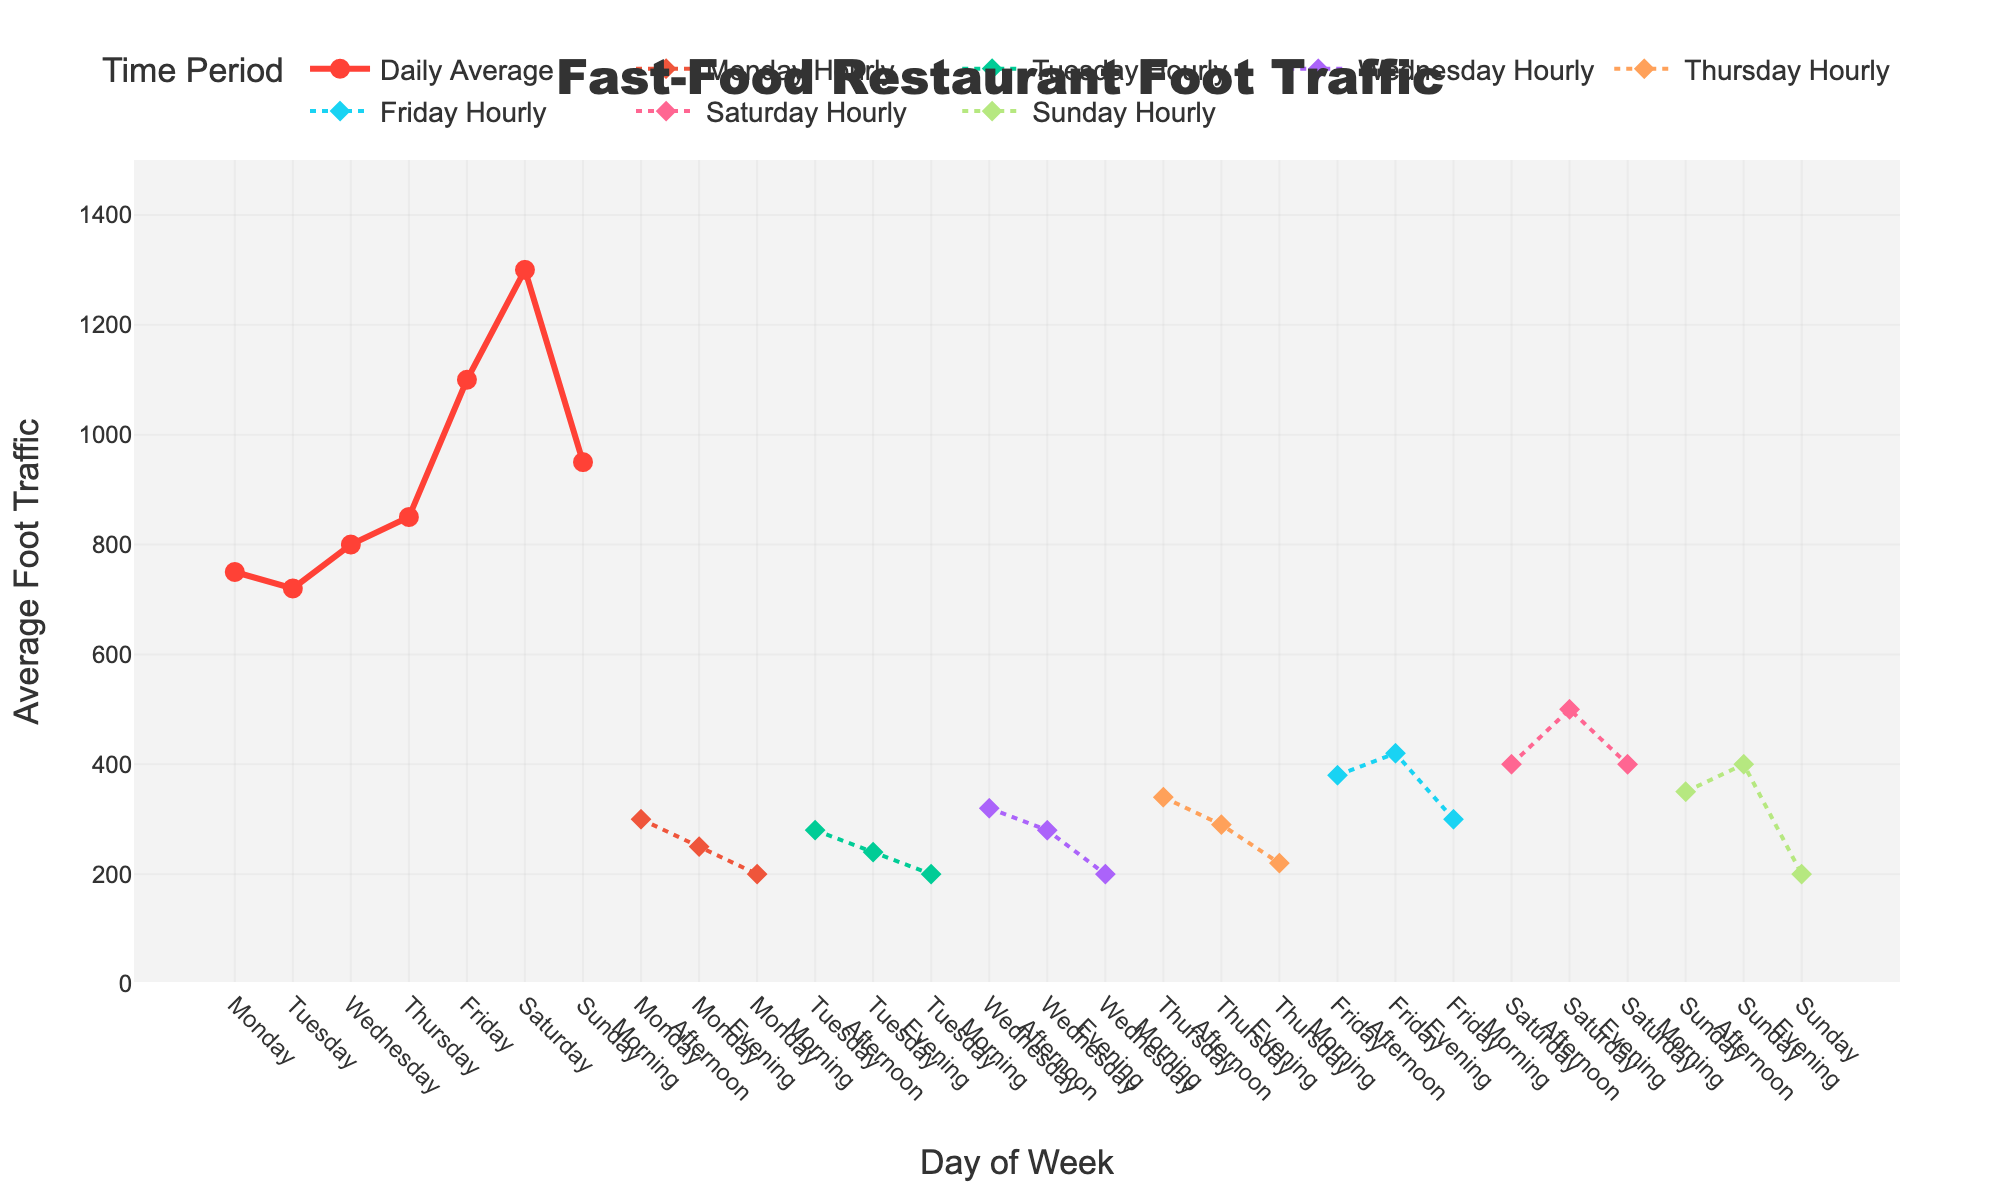What day has the highest average foot traffic? Look at the daily foot traffic data points and compare them. The highest value is on Saturday, with an average foot traffic of 1300.
Answer: Saturday What is the difference in foot traffic between Friday and Sunday? Subtract the average foot traffic on Sunday from the average foot traffic on Friday. That is 1100 - 950 = 150.
Answer: 150 Which time period on Saturday has the highest foot traffic? Check the hourly breakdown for Saturday. Morning is 400, afternoon is 500, and evening is 400. The highest is afternoon at 500.
Answer: Afternoon How much does Monday’s daily average foot traffic exceed Monday's evening foot traffic? Subtract the evening foot traffic from the daily average. Monday's daily average is 750, and evening foot traffic is 200. Therefore, 750 - 200 = 550.
Answer: 550 On which day does the morning foot traffic exceed the evening foot traffic by the largest amount? Calculate the difference between morning and evening foot traffic for each day. The largest difference is on Saturday (400 - 400 = 0), Friday (380 - 300 = 80), Thursday (340 - 220 = 120), etc. The largest difference is on Thursday, with 120.
Answer: Thursday What is the total foot traffic on Wednesday, summing up all periods? Add morning, afternoon, and evening foot traffic for Wednesday. Morning is 320, afternoon is 280, and evening is 200. So, 320 + 280 + 200 = 800.
Answer: 800 Is the daily average foot traffic on Thursday greater than the combined morning and afternoon foot traffic on the same day? Compare Thursday's daily average of 850 with the combined morning and afternoon traffic (340 + 290 = 630). 850 is indeed greater than 630.
Answer: Yes On which day does the combined afternoon and evening foot traffic match the following day's morning foot traffic? Calculate the sum for each day and compare it with the next day's morning traffic. Sunday’s afternoon (400) and evening (200) total 600, which matches Monday morning's foot traffic of 300.
Answer: Sunday Which day shows the least variation between morning and evening foot traffic? Calculate the difference for each day between morning and evening foot traffic. The smallest difference is on Monday (300 - 200 = 100).
Answer: Monday 